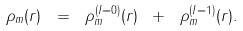<formula> <loc_0><loc_0><loc_500><loc_500>\rho _ { m } ( r ) \ = \ \rho _ { m } ^ { ( I = 0 ) } ( r ) \ + \ \rho _ { m } ^ { ( I = 1 ) } ( r ) .</formula> 